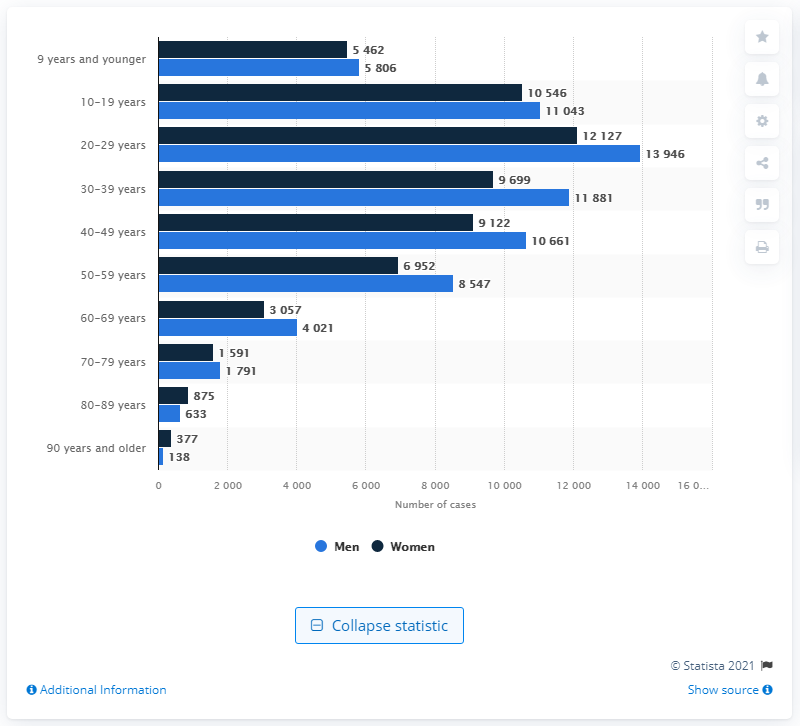List a handful of essential elements in this visual. As of June 14, 2021, a total of 13,946 men in Norway had tested positive for COVID-19. 